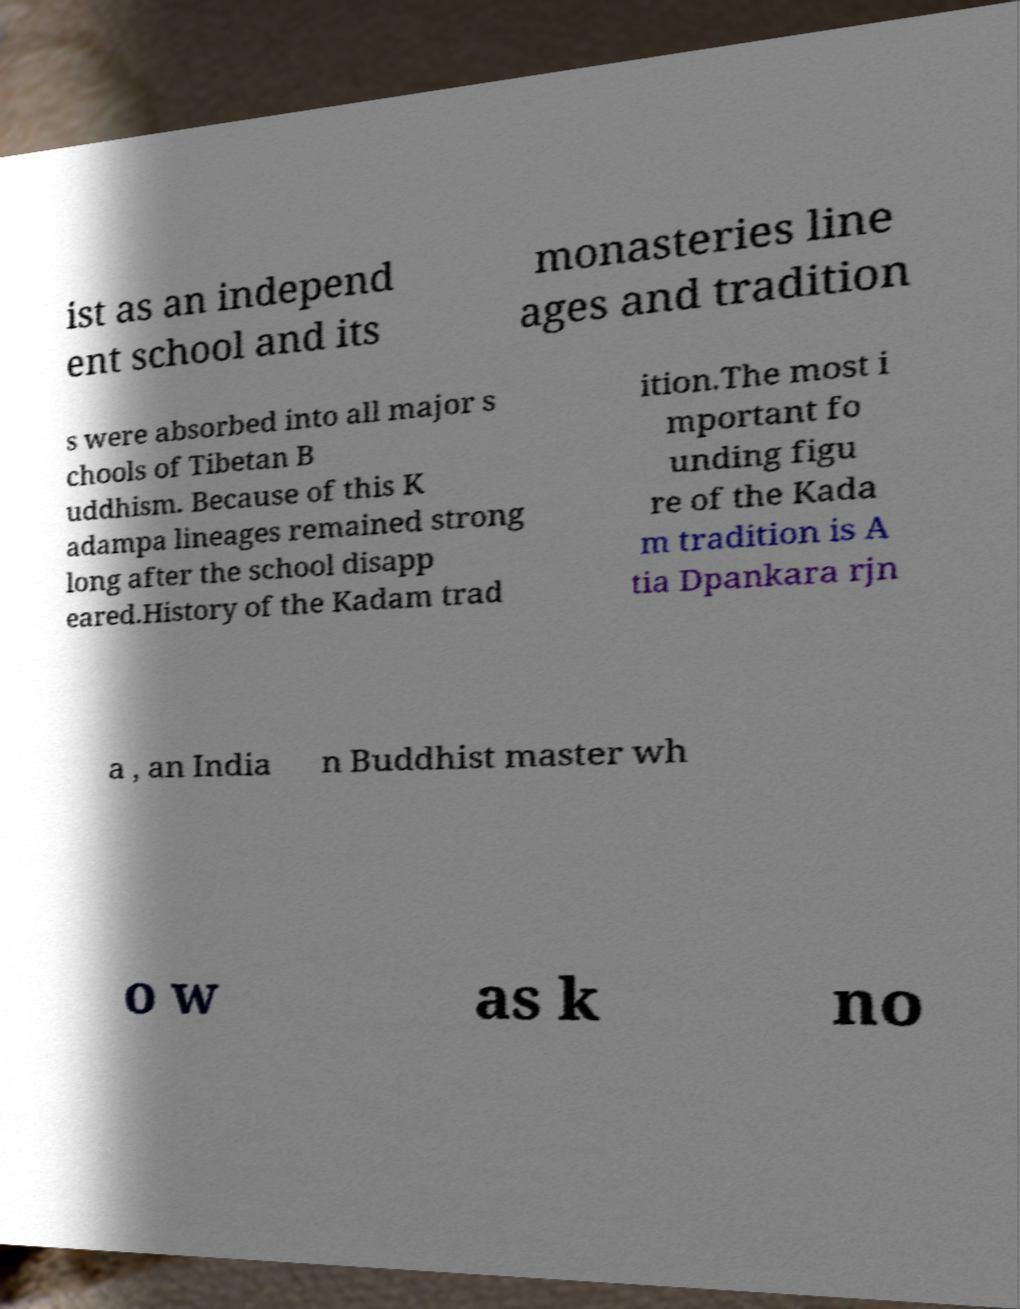Can you read and provide the text displayed in the image?This photo seems to have some interesting text. Can you extract and type it out for me? ist as an independ ent school and its monasteries line ages and tradition s were absorbed into all major s chools of Tibetan B uddhism. Because of this K adampa lineages remained strong long after the school disapp eared.History of the Kadam trad ition.The most i mportant fo unding figu re of the Kada m tradition is A tia Dpankara rjn a , an India n Buddhist master wh o w as k no 